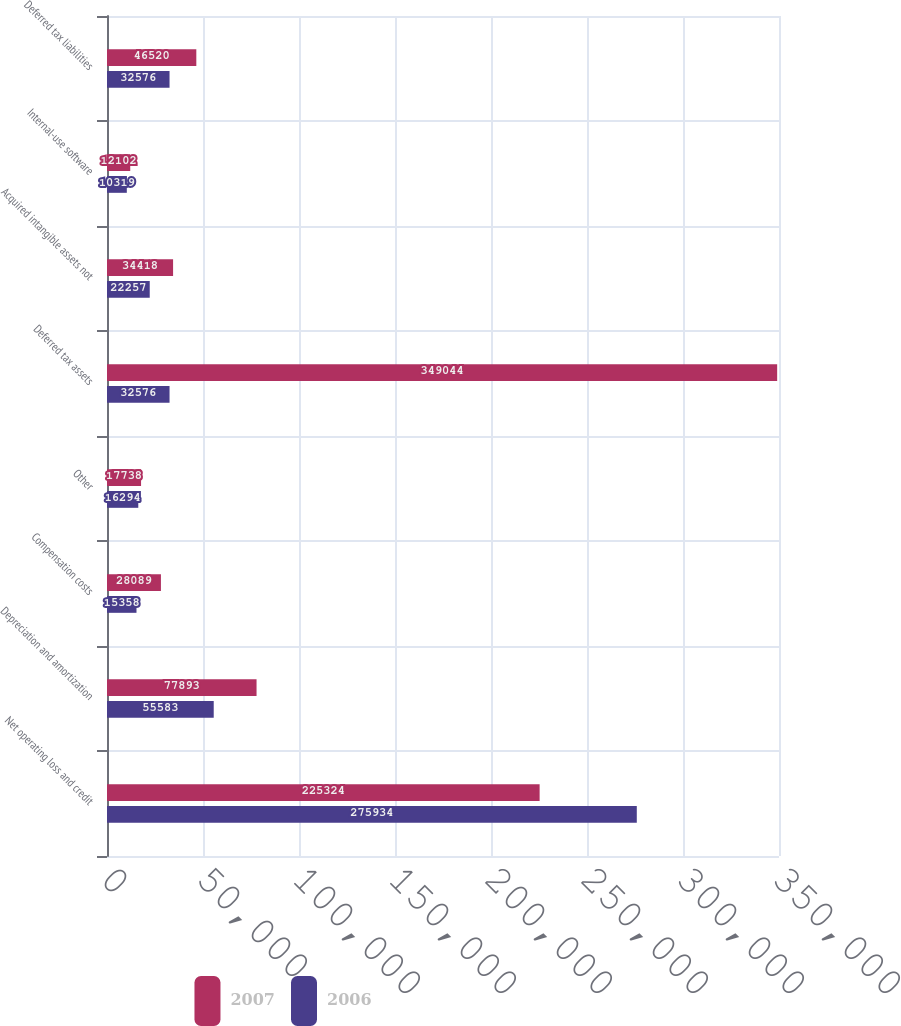Convert chart. <chart><loc_0><loc_0><loc_500><loc_500><stacked_bar_chart><ecel><fcel>Net operating loss and credit<fcel>Depreciation and amortization<fcel>Compensation costs<fcel>Other<fcel>Deferred tax assets<fcel>Acquired intangible assets not<fcel>Internal-use software<fcel>Deferred tax liabilities<nl><fcel>2007<fcel>225324<fcel>77893<fcel>28089<fcel>17738<fcel>349044<fcel>34418<fcel>12102<fcel>46520<nl><fcel>2006<fcel>275934<fcel>55583<fcel>15358<fcel>16294<fcel>32576<fcel>22257<fcel>10319<fcel>32576<nl></chart> 